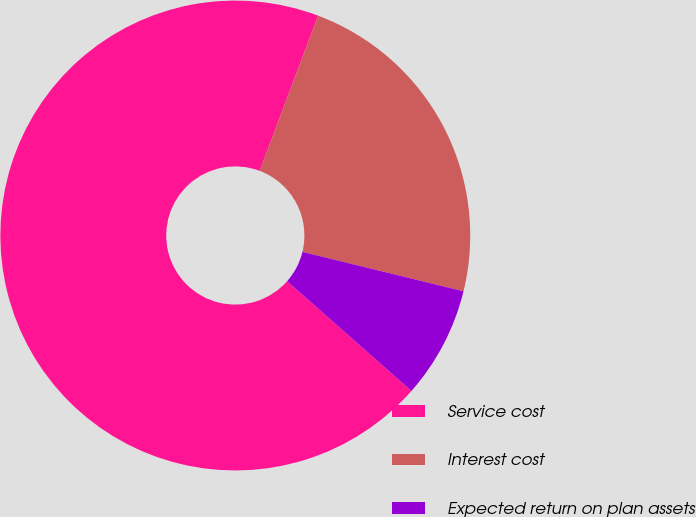<chart> <loc_0><loc_0><loc_500><loc_500><pie_chart><fcel>Service cost<fcel>Interest cost<fcel>Expected return on plan assets<nl><fcel>69.23%<fcel>23.08%<fcel>7.69%<nl></chart> 